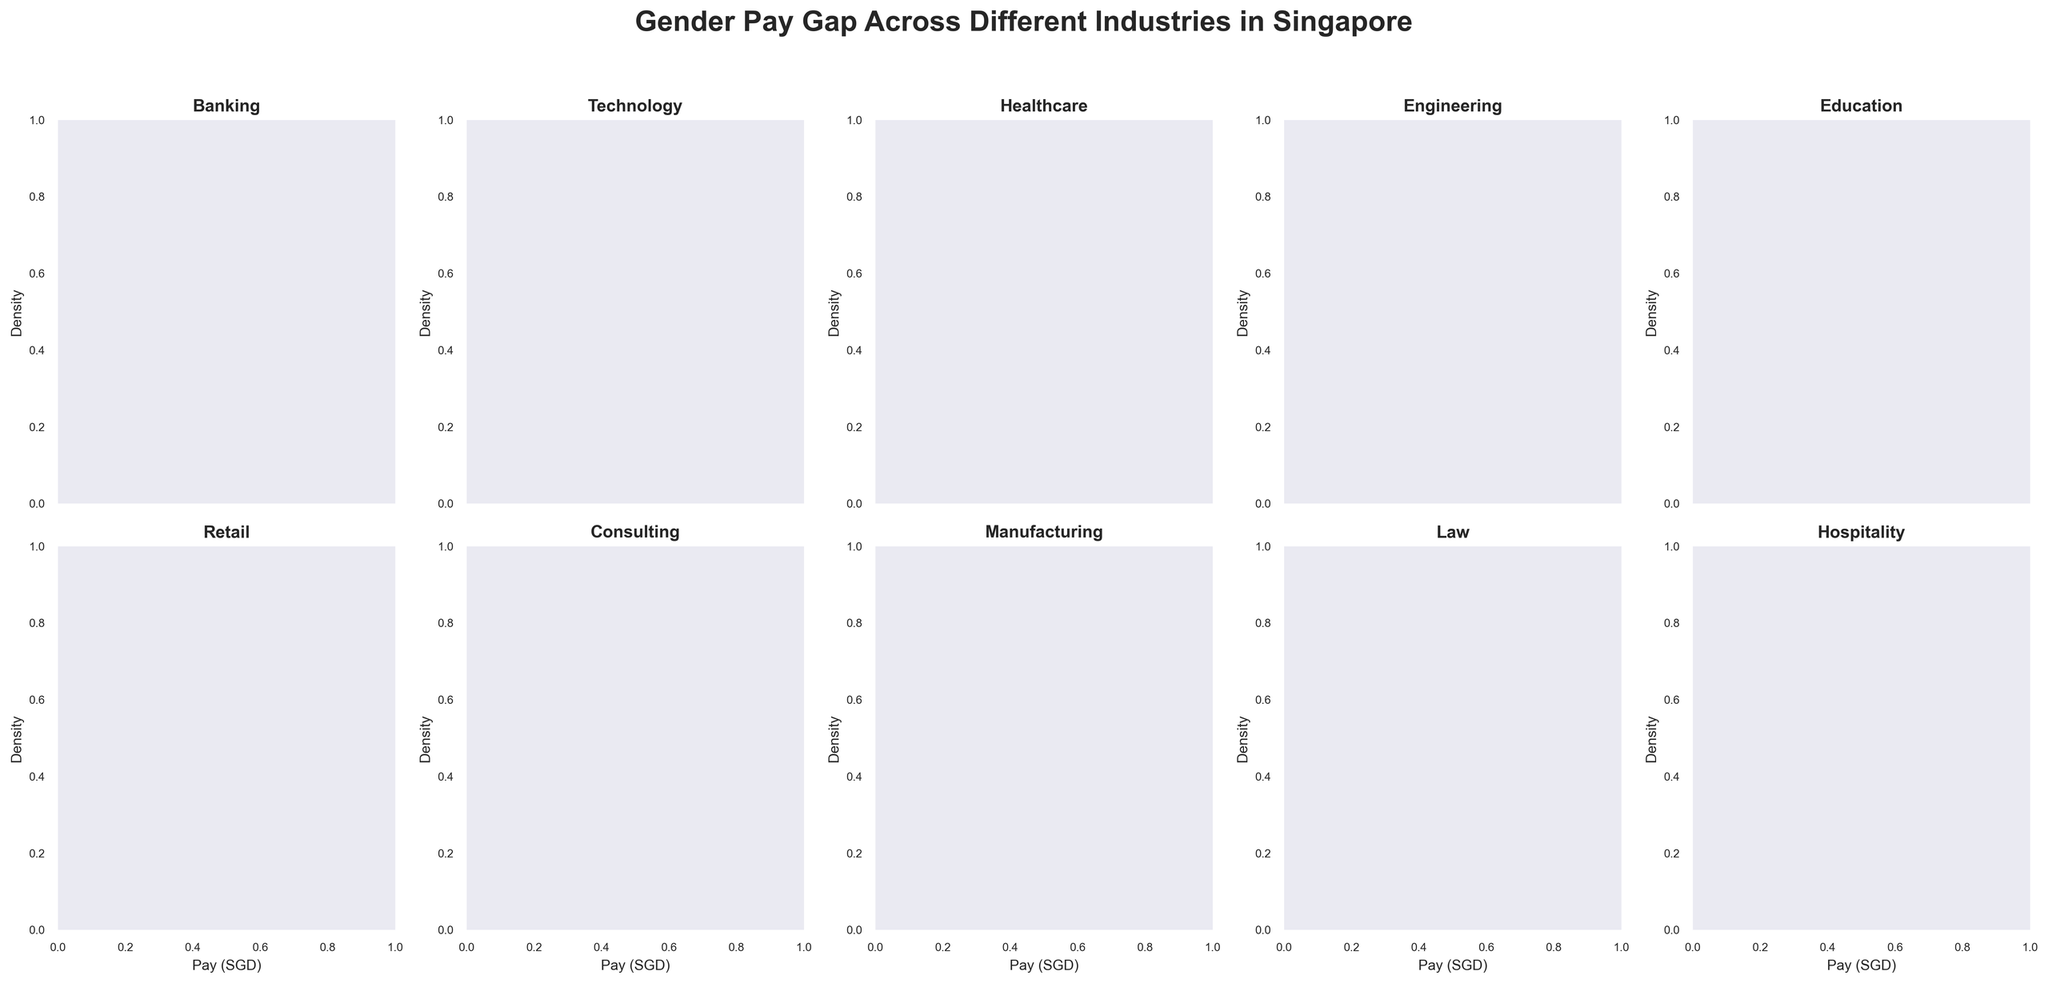What is the title of the figure? The title is mentioned at the top of the figure. It reads: "Gender Pay Gap Across Different Industries in Singapore."
Answer: Gender Pay Gap Across Different Industries in Singapore What are the axes labels used in the plots? The x-axis is labeled as "Pay (SGD)" and the y-axis is labeled as "Density."
Answer: Pay (SGD) and Density How many industries are represented in the figure? The figure contains 10 subplots representing different industries. Each subplot shows one of the industries.
Answer: 10 Which industry shows the highest density for male pay? By observing the subplots, the distribution curve with the highest density for males is in the Consulting industry, where it reaches a notable peak.
Answer: Consulting In the Healthcare industry, what is the approximate peak density for female pay? From the Healthcare subplot, we can see that the peak density of female pay is somewhat less than the male's, approximately around 0.0001.
Answer: 0.0001 Which gender has a higher maximum pay density in the Education industry? In the Education subplot, the density curve for male pay is slightly higher than that for females. Thus, the male has a higher maximum density.
Answer: Male Compare the peaks of male and female density curves in the Technology industry. Which one is higher and by how much approximately? In the Technology industry subplot, the male density curve reaches a peak that is slightly higher than the female's. The difference between the male and female density curve peaks is approximately 0.00005.
Answer: Male by 0.00005 What is the general trend in the pay distribution across industries for females compared to males? By observing all subplots, we notice that for most industries, the pay density for females tends to be marginally lower compared to males, generally indicating a pay gap where males tend to earn more.
Answer: Females generally have lower pay densities compared to males What can you infer about the gender pay gap in the Retail industry from the density plots? In the Retail subplot, the density curves for both males and females are very close to each other, which suggests that the gender pay gap in this industry might be smaller compared to other industries.
Answer: Smaller gender pay gap In which industry is the difference between male and female pay densities most pronounced? By examining the subplots, the Manufacturing industry shows a significant difference between male and female pay densities, indicating a pronounced pay gap.
Answer: Manufacturing 